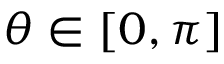Convert formula to latex. <formula><loc_0><loc_0><loc_500><loc_500>\theta \in [ 0 , \pi ]</formula> 